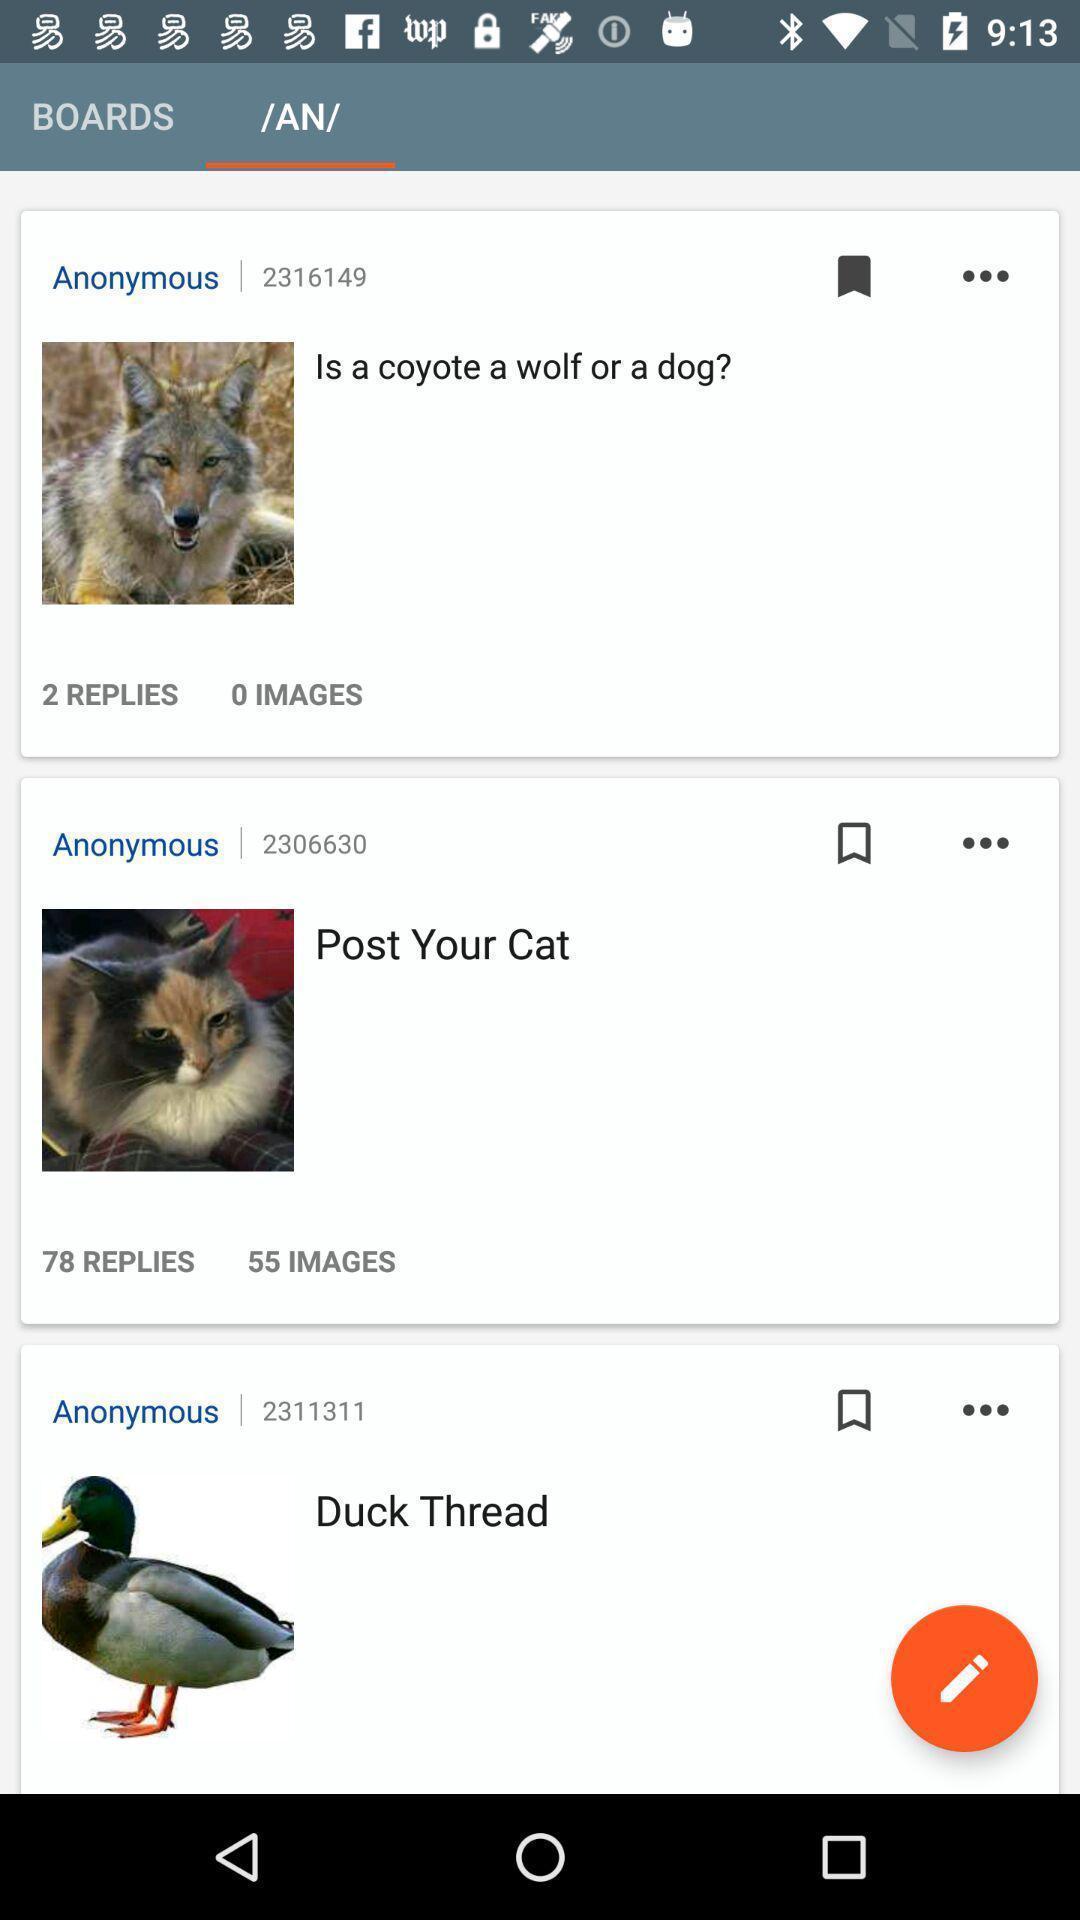Tell me about the visual elements in this screen capture. Page displaying photos of animals and texts. 